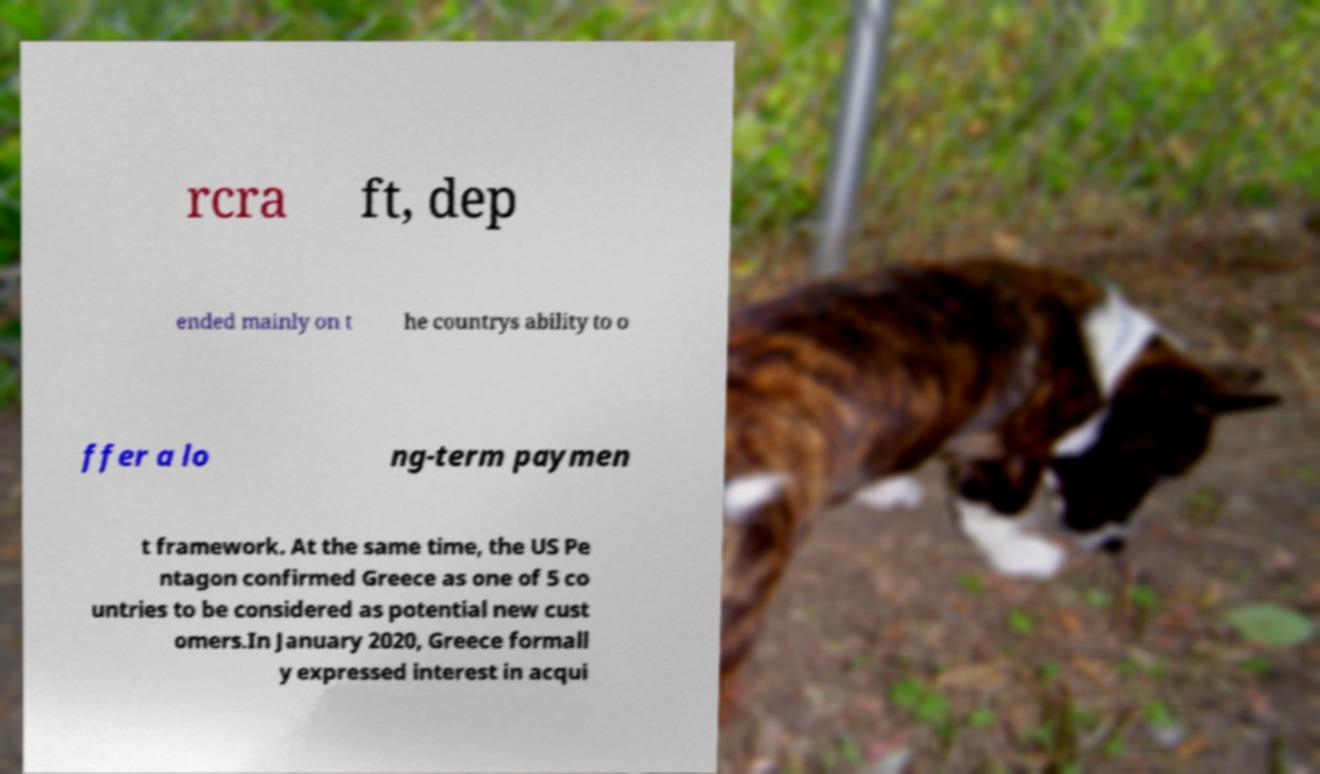Could you extract and type out the text from this image? rcra ft, dep ended mainly on t he countrys ability to o ffer a lo ng-term paymen t framework. At the same time, the US Pe ntagon confirmed Greece as one of 5 co untries to be considered as potential new cust omers.In January 2020, Greece formall y expressed interest in acqui 